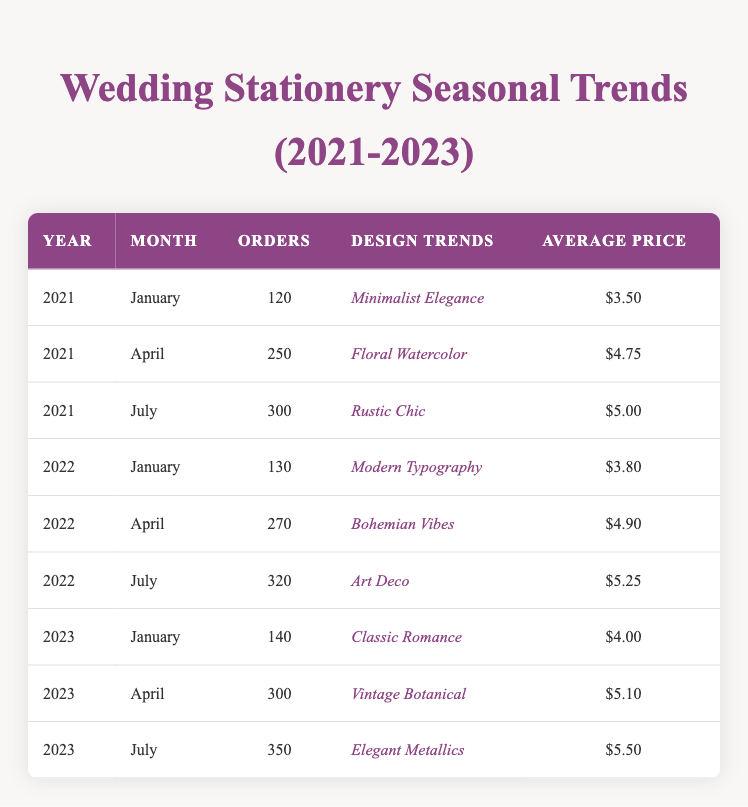What were the total orders in July across the three years? To find the total orders in July, we need to look at the orders for each year: 300 in July 2021, 320 in July 2022, and 350 in July 2023. We sum these values: 300 + 320 + 350 = 970.
Answer: 970 Which month in 2022 saw the highest number of orders? By examining the data for 2022, we see the orders: January had 130, April had 270, and July had 320. The month with the highest orders is July with 320.
Answer: July Did the Average Price increase from 2022 to 2023? The average prices for 2022 are 3.80 in January, 4.90 in April, and 5.25 in July. For 2023, they are 4.00 in January, 5.10 in April, and 5.50 in July. Comparing these values, January saw an increase, April remained higher in 2022, and July also increased. Considering the overall prices, yes, there was an increase from 2022 to 2023.
Answer: Yes What is the average number of orders for all months in 2021? For 2021, there are three months where the orders are: 120 in January, 250 in April, and 300 in July. The total orders are 120 + 250 + 300 = 670. Dividing this by the number of months (3) gives an average of 670/3 = 223.33.
Answer: 223.33 Which design trend had the highest average price in 2023, and what was that price? In 2023, the design trends are Classic Romance ($4.00), Vintage Botanical ($5.10), and Elegant Metallics ($5.50). The highest average price is for Elegant Metallics at $5.50.
Answer: Elegant Metallics, $5.50 Is it true that "Rustic Chic" was the design trend for July 2021? According to the table, July 2021 listed "Rustic Chic" as the design trend. Therefore, the statement is true.
Answer: Yes What was the percentage increase in orders from April 2021 to April 2022? For April 2021, the orders were 250, and for April 2022, they were 270. The difference is 270 - 250 = 20. To find the percentage increase: (20/250) * 100 = 8%.
Answer: 8% How many months had more than 300 orders across the three years? By checking each month: July 2021 (300), July 2022 (320), and July 2023 (350) have orders of 300 or more. Thus, the months with more than 300 orders are July 2022 (320) and July 2023 (350). This gives us 2 months in total.
Answer: 2 What is the total average price of design trends for all three years? The average prices for all months from 2021 to 2023 are as follows: 3.50 (Jan 2021), 4.75 (Apr 2021), 5.00 (Jul 2021), 3.80 (Jan 2022), 4.90 (Apr 2022), 5.25 (Jul 2022), 4.00 (Jan 2023), 5.10 (Apr 2023), 5.50 (Jul 2023). The sum of these prices is 3.50 + 4.75 + 5.00 + 3.80 + 4.90 + 5.25 + 4.00 + 5.10 + 5.50 = 42.80. The total number of months is 9, giving an average of 42.80/9 = 4.76.
Answer: 4.76 